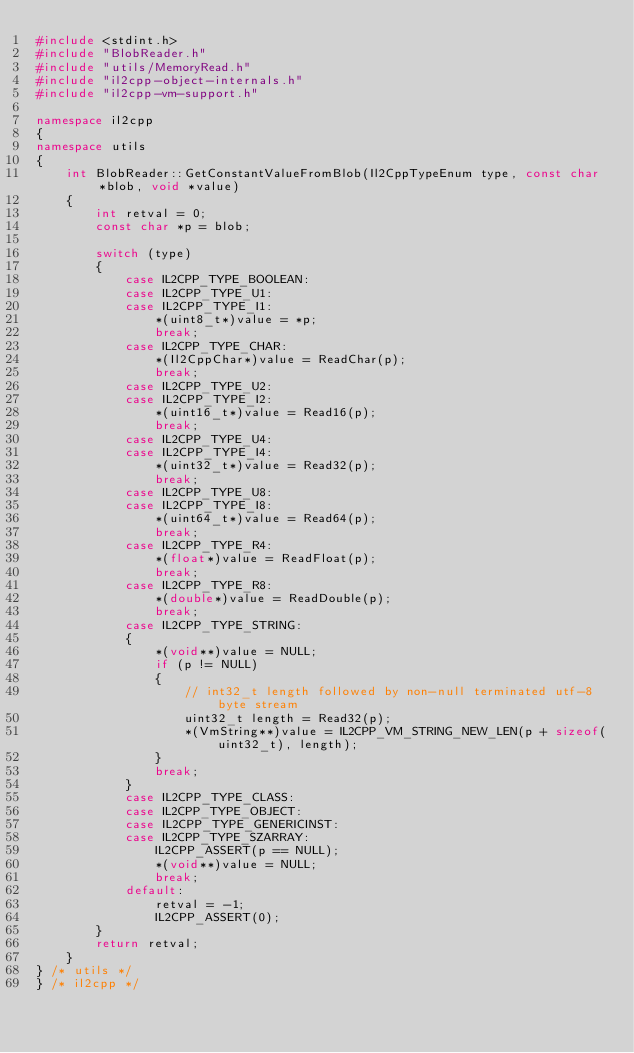<code> <loc_0><loc_0><loc_500><loc_500><_C++_>#include <stdint.h>
#include "BlobReader.h"
#include "utils/MemoryRead.h"
#include "il2cpp-object-internals.h"
#include "il2cpp-vm-support.h"

namespace il2cpp
{
namespace utils
{
    int BlobReader::GetConstantValueFromBlob(Il2CppTypeEnum type, const char *blob, void *value)
    {
        int retval = 0;
        const char *p = blob;

        switch (type)
        {
            case IL2CPP_TYPE_BOOLEAN:
            case IL2CPP_TYPE_U1:
            case IL2CPP_TYPE_I1:
                *(uint8_t*)value = *p;
                break;
            case IL2CPP_TYPE_CHAR:
                *(Il2CppChar*)value = ReadChar(p);
                break;
            case IL2CPP_TYPE_U2:
            case IL2CPP_TYPE_I2:
                *(uint16_t*)value = Read16(p);
                break;
            case IL2CPP_TYPE_U4:
            case IL2CPP_TYPE_I4:
                *(uint32_t*)value = Read32(p);
                break;
            case IL2CPP_TYPE_U8:
            case IL2CPP_TYPE_I8:
                *(uint64_t*)value = Read64(p);
                break;
            case IL2CPP_TYPE_R4:
                *(float*)value = ReadFloat(p);
                break;
            case IL2CPP_TYPE_R8:
                *(double*)value = ReadDouble(p);
                break;
            case IL2CPP_TYPE_STRING:
            {
                *(void**)value = NULL;
                if (p != NULL)
                {
                    // int32_t length followed by non-null terminated utf-8 byte stream
                    uint32_t length = Read32(p);
                    *(VmString**)value = IL2CPP_VM_STRING_NEW_LEN(p + sizeof(uint32_t), length);
                }
                break;
            }
            case IL2CPP_TYPE_CLASS:
            case IL2CPP_TYPE_OBJECT:
            case IL2CPP_TYPE_GENERICINST:
            case IL2CPP_TYPE_SZARRAY:
                IL2CPP_ASSERT(p == NULL);
                *(void**)value = NULL;
                break;
            default:
                retval = -1;
                IL2CPP_ASSERT(0);
        }
        return retval;
    }
} /* utils */
} /* il2cpp */
</code> 